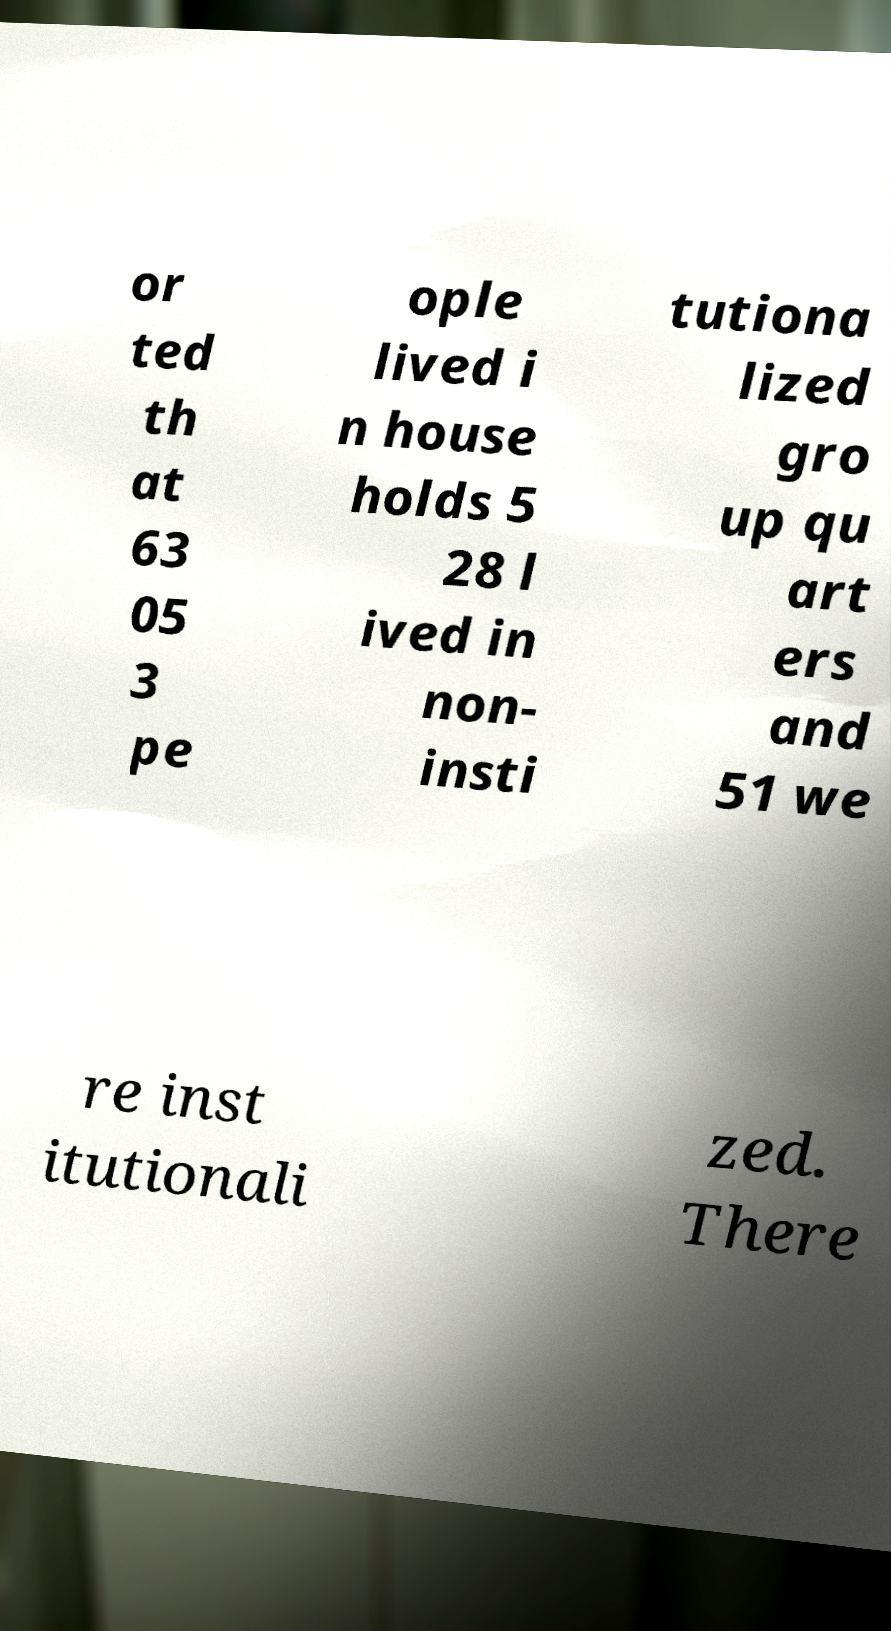Can you read and provide the text displayed in the image?This photo seems to have some interesting text. Can you extract and type it out for me? or ted th at 63 05 3 pe ople lived i n house holds 5 28 l ived in non- insti tutiona lized gro up qu art ers and 51 we re inst itutionali zed. There 